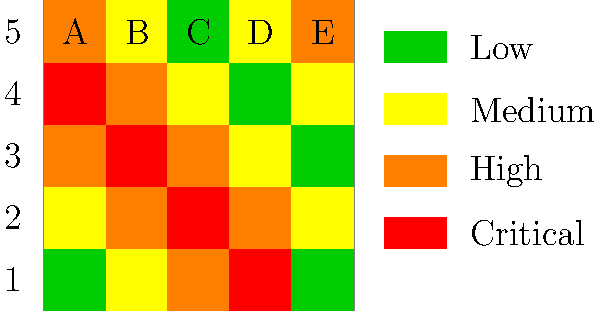Based on the color-coded heat map representing risk levels in different areas, which location has the highest concentration of critical risk zones, and what strategic approach would you recommend for allocating counterterrorism resources? To answer this question, we need to analyze the heat map systematically:

1. Understand the color coding:
   - Green: Low risk
   - Yellow: Medium risk
   - Orange: High risk
   - Red: Critical risk

2. Examine the grid:
   - The map is divided into a 5x5 grid
   - Columns are labeled A to E
   - Rows are labeled 1 to 5

3. Identify critical risk zones (red squares):
   - A4
   - B3
   - C2

4. Analyze the distribution of critical zones:
   - The critical zones form a diagonal line from top-left to bottom-right
   - The highest concentration is in the center of the map (B3)

5. Consider surrounding high-risk areas:
   - Areas adjacent to critical zones are mostly high risk (orange)
   - This creates a larger area of concern around the critical zones

6. Strategic approach for resource allocation:
   a) Focus on the central area (B3) as the primary target
   b) Establish a perimeter around the diagonal line of critical and high-risk zones
   c) Implement a gradient approach, with resources decreasing as risk levels decrease
   d) Maintain flexibility to respond to changes in risk levels
   e) Coordinate with local authorities in medium-risk areas for increased vigilance

7. Continuous monitoring:
   - Regularly update the heat map based on new intelligence
   - Adjust resource allocation as risk levels change

Given this analysis, the location with the highest concentration of critical risk zones is the central area, specifically B3, due to its critical status and proximity to other high-risk areas. The strategic approach should prioritize this central location while maintaining coverage of the diagonal line of high-risk areas.
Answer: Central area (B3); prioritize central location, establish perimeter around diagonal high-risk line, implement gradient approach for resource allocation. 